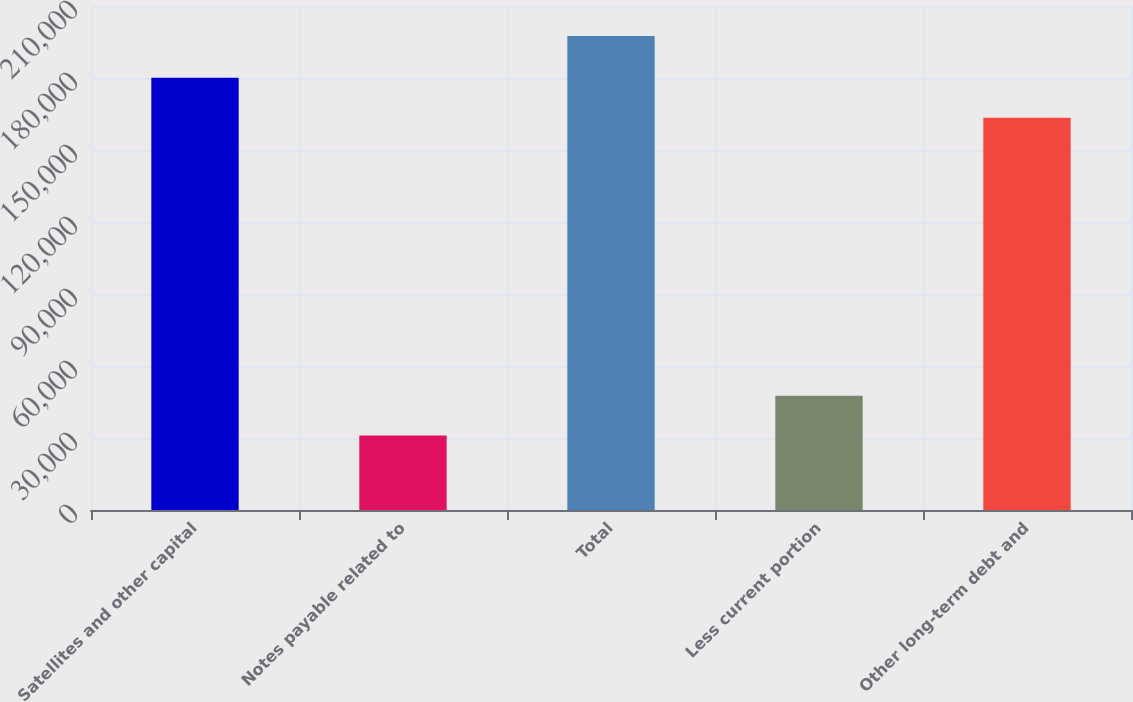<chart> <loc_0><loc_0><loc_500><loc_500><bar_chart><fcel>Satellites and other capital<fcel>Notes payable related to<fcel>Total<fcel>Less current portion<fcel>Other long-term debt and<nl><fcel>180137<fcel>30996<fcel>197488<fcel>47645.2<fcel>163488<nl></chart> 